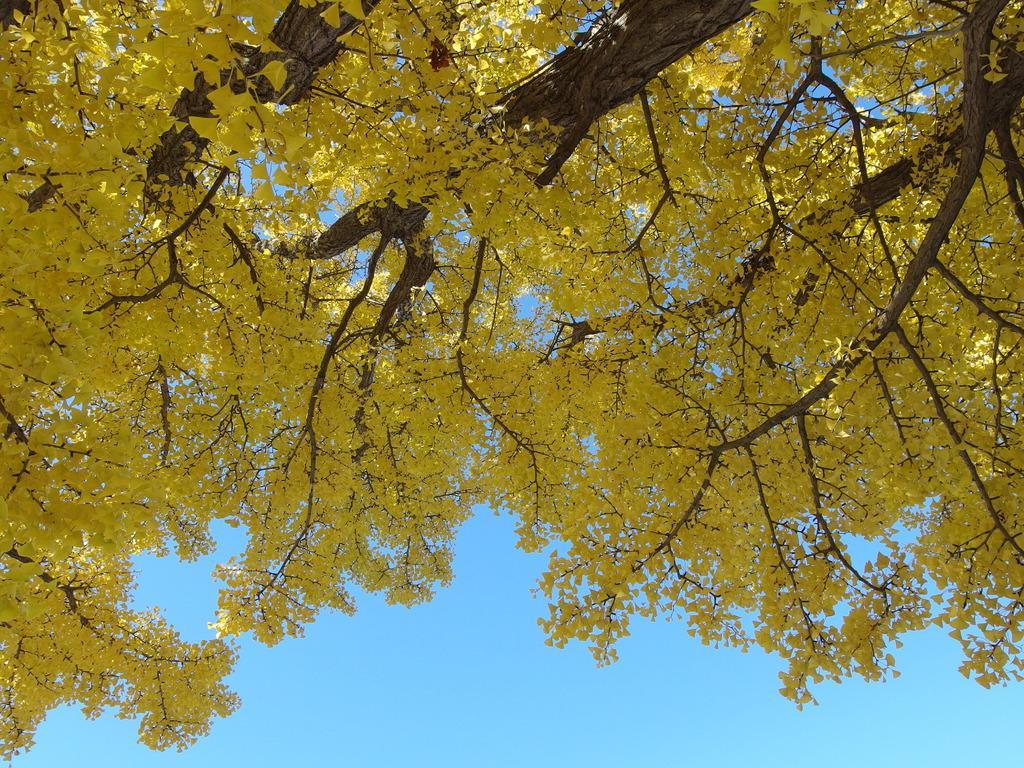Describe this image in one or two sentences. In this image I can see few trees in the front and in the background I can see the sky. I can see color of these leaves are yellow. 